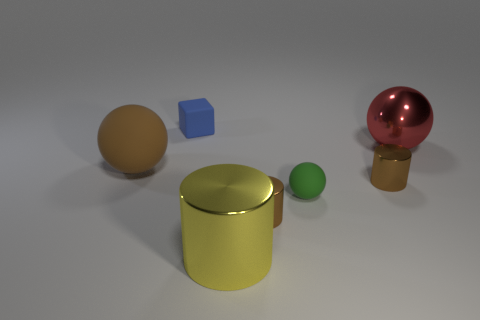What might be the purpose of arranging these objects together in this way? This arrangement looks like a still-life composition, possibly for the purpose of a rendering or lighting test. The different colors and shapes provide a variety of surfaces to observe reflections, highlights, and shadows, which can be helpful for someone working in visual design or computer graphics to assess the rendering capabilities of a software or to showcase different material properties. 